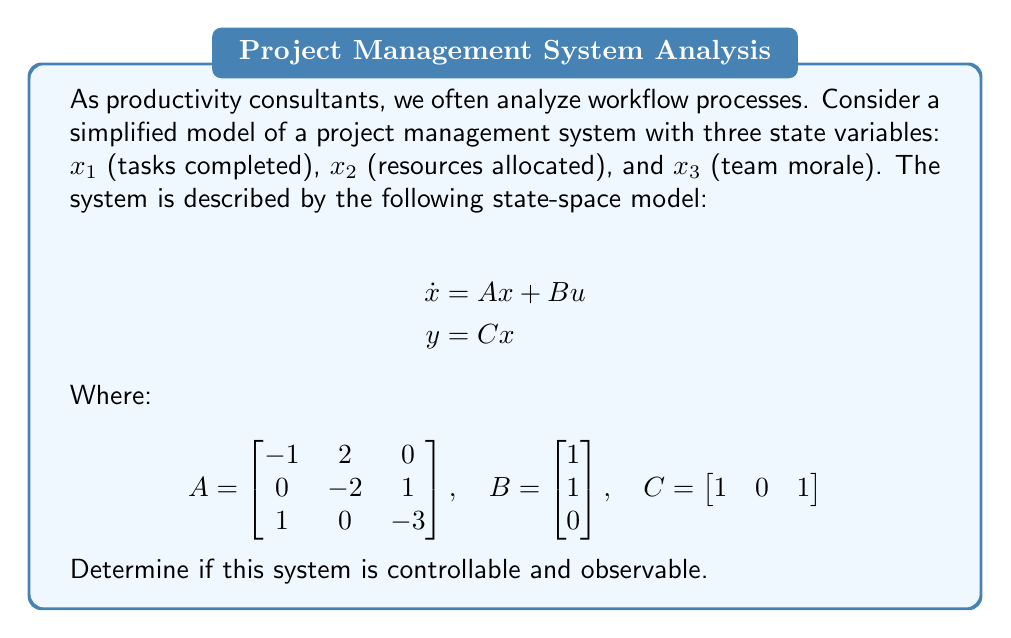What is the answer to this math problem? To analyze the controllability and observability of this system, we need to check the rank of the controllability and observability matrices.

1. Controllability:
   The controllability matrix is given by $\mathcal{C} = [B \quad AB \quad A^2B]$

   First, calculate $AB$:
   $$AB = \begin{bmatrix}
   -1 & 2 & 0 \\
   0 & -2 & 1 \\
   1 & 0 & -3
   \end{bmatrix}
   \begin{bmatrix}
   1 \\
   1 \\
   0
   \end{bmatrix} =
   \begin{bmatrix}
   1 \\
   -2 \\
   1
   \end{bmatrix}$$

   Then, calculate $A^2B$:
   $$A^2B = A(AB) = \begin{bmatrix}
   -1 & 2 & 0 \\
   0 & -2 & 1 \\
   1 & 0 & -3
   \end{bmatrix}
   \begin{bmatrix}
   1 \\
   -2 \\
   1
   \end{bmatrix} =
   \begin{bmatrix}
   -5 \\
   5 \\
   -2
   \end{bmatrix}$$

   Now, form the controllability matrix:
   $$\mathcal{C} = [B \quad AB \quad A^2B] = 
   \begin{bmatrix}
   1 & 1 & -5 \\
   1 & -2 & 5 \\
   0 & 1 & -2
   \end{bmatrix}$$

   The rank of $\mathcal{C}$ is 3 (full rank), so the system is controllable.

2. Observability:
   The observability matrix is given by $\mathcal{O} = [C^T \quad A^TC^T \quad (A^T)^2C^T]$

   First, calculate $A^TC^T$:
   $$A^TC^T = \begin{bmatrix}
   -1 & 0 & 1 \\
   2 & -2 & 0 \\
   0 & 1 & -3
   \end{bmatrix}
   \begin{bmatrix}
   1 \\
   0 \\
   1
   \end{bmatrix} =
   \begin{bmatrix}
   0 \\
   2 \\
   -3
   \end{bmatrix}$$

   Then, calculate $(A^T)^2C^T$:
   $$(A^T)^2C^T = A^T(A^TC^T) = \begin{bmatrix}
   -1 & 0 & 1 \\
   2 & -2 & 0 \\
   0 & 1 & -3
   \end{bmatrix}
   \begin{bmatrix}
   0 \\
   2 \\
   -3
   \end{bmatrix} =
   \begin{bmatrix}
   -3 \\
   -4 \\
   9
   \end{bmatrix}$$

   Now, form the observability matrix:
   $$\mathcal{O} = [C^T \quad A^TC^T \quad (A^T)^2C^T] = 
   \begin{bmatrix}
   1 & 0 & -3 \\
   0 & 2 & -4 \\
   1 & -3 & 9
   \end{bmatrix}$$

   The rank of $\mathcal{O}$ is 3 (full rank), so the system is observable.
Answer: The system is both controllable and observable. 